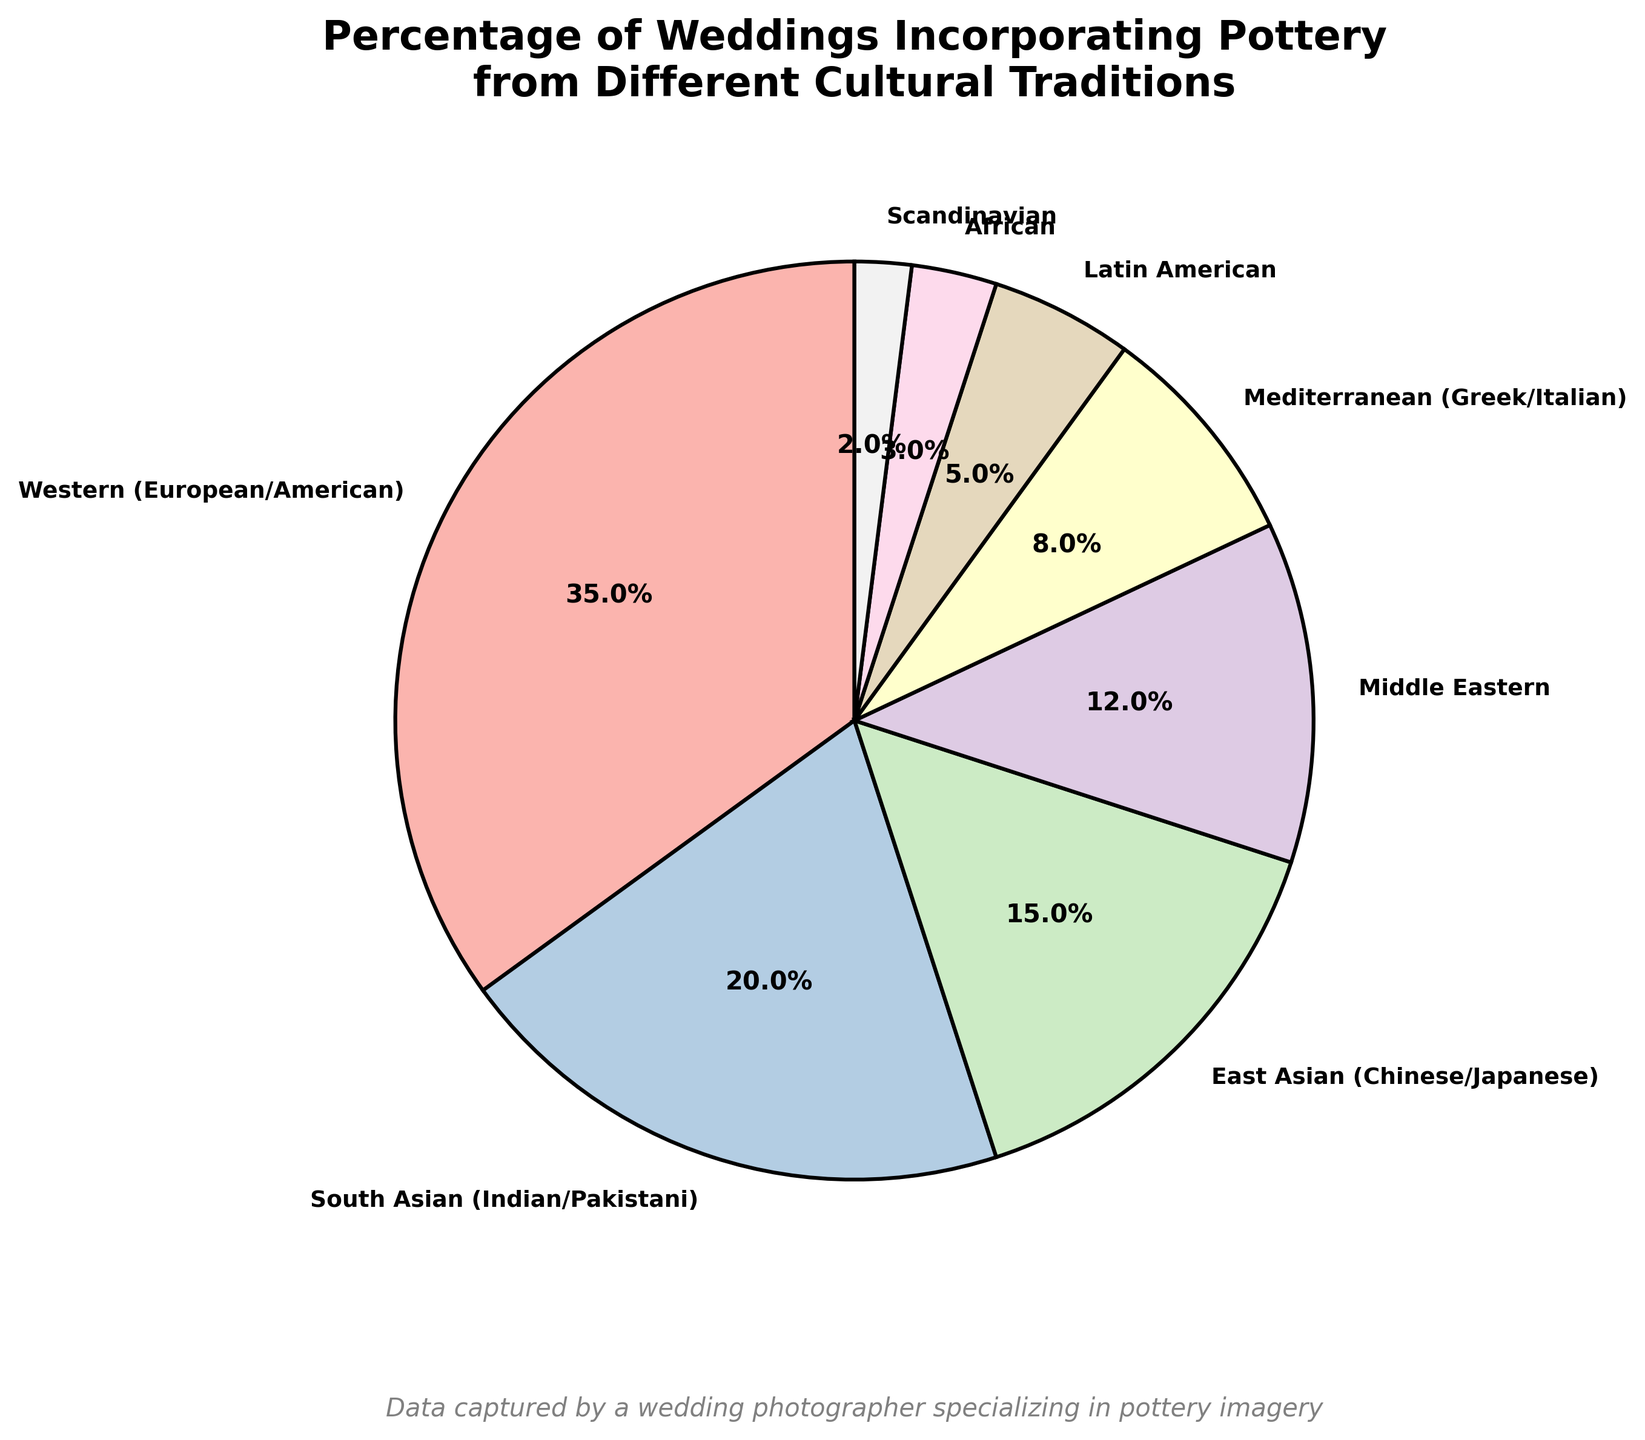What percentage of weddings incorporate pottery from Western traditions? The pie chart indicates the percentage of weddings incorporating pottery from different cultural traditions. The slice labeled "Western (European/American)" shows a percentage of 35%.
Answer: 35% What is the combined percentage of weddings that incorporate pottery from South Asian and East Asian traditions? To find the combined percentage, add the percentages of South Asian weddings (20%) and East Asian weddings (15%). 20% + 15% = 35%
Answer: 35% Which tradition has the smallest percentage of weddings incorporating pottery? The smallest slice on the pie chart is labeled "Scandinavian," which has a percentage of 2%.
Answer: Scandinavian Is the combined percentage of Middle Eastern and Mediterranean weddings greater than that of Western weddings? The percentage for Middle Eastern weddings is 12% and for Mediterranean weddings is 8%. Together, they sum to 12% + 8% = 20%. Western weddings have a percentage of 35%, which is greater than 20%.
Answer: No What percentage more do weddings from Western traditions incorporate pottery compared to Latin American traditions? Western weddings incorporate pottery at a percentage of 35%, while Latin American weddings do so at 5%. The difference is 35% - 5% = 30%.
Answer: 30% How do the percentages of South Asian and East Asian pottery usage compare to each other? The pie chart shows South Asian weddings at 20% and East Asian weddings at 15%. Comparing these, South Asian weddings have a higher percentage by 5%.
Answer: South Asian is higher by 5% What is the cumulative percentage of weddings from African and Scandinavian traditions incorporating pottery? The pie chart shows African weddings at 3% and Scandinavian weddings at 2%. Adding them together gives 3% + 2% = 5%.
Answer: 5% What tradition accounts for 12% of the total weddings incorporating pottery? The slice labeled "Middle Eastern" has a percentage of 12%.
Answer: Middle Eastern Which two traditions together just match the percentage of South Asian weddings? South Asian weddings are at 20%. Latin American is 5% and African is 3%. Adding Mediterranean (8%) and Latin American (5%) gives 8% + 5% = 13%. Adding Scandinavian (2%) and Latin American (5%) gives 2% + 5% = 7%. Combining Middle Eastern (12%) and Mediterranean (8%) gives 12% + 8% = 20%. Only Middle Eastern + Mediterranean equals South Asian.
Answer: Middle Eastern and Mediterranean 